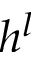<formula> <loc_0><loc_0><loc_500><loc_500>h ^ { l }</formula> 